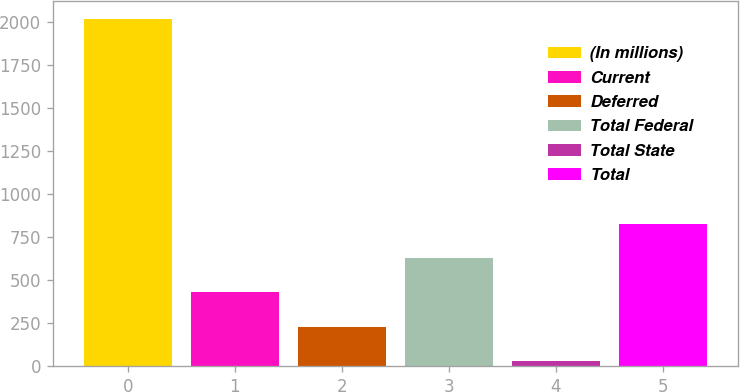Convert chart. <chart><loc_0><loc_0><loc_500><loc_500><bar_chart><fcel>(In millions)<fcel>Current<fcel>Deferred<fcel>Total Federal<fcel>Total State<fcel>Total<nl><fcel>2017<fcel>429<fcel>230.5<fcel>627.5<fcel>32<fcel>826<nl></chart> 